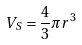Convert formula to latex. <formula><loc_0><loc_0><loc_500><loc_500>V _ { S } = \frac { 4 } { 3 } \pi r ^ { 3 }</formula> 